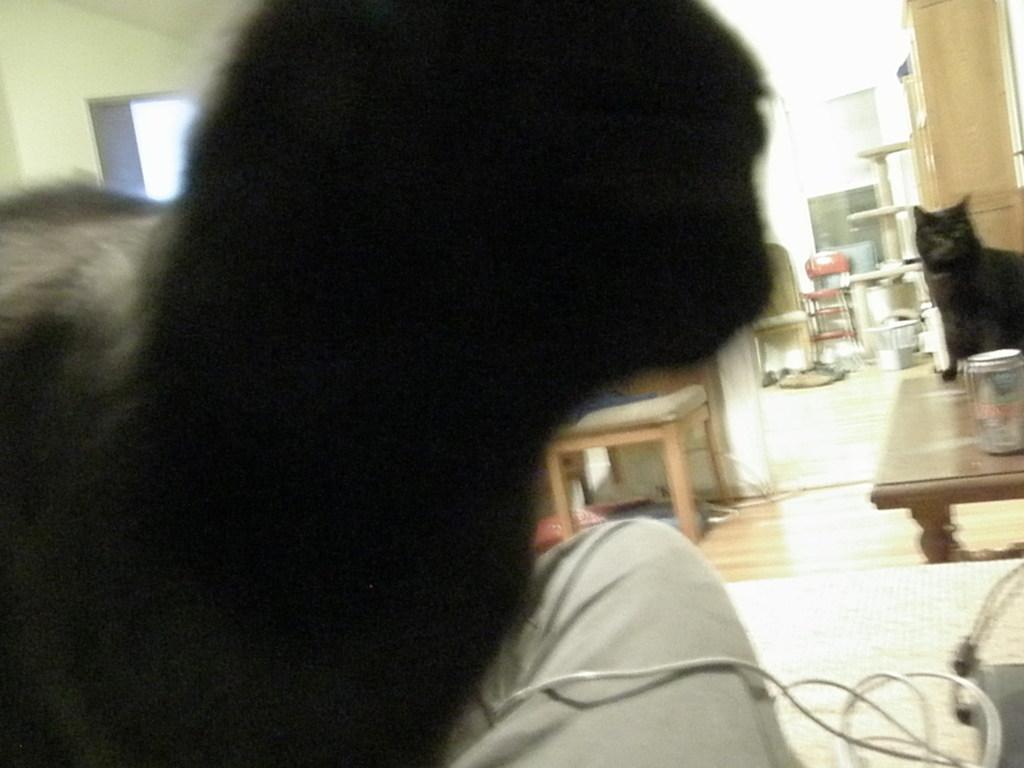Describe this image in one or two sentences. Here we see a table on the floor, and cat and tin on it, and here is the table and at back her is the chair and some objects, and here is the wall, and here is the hair, 